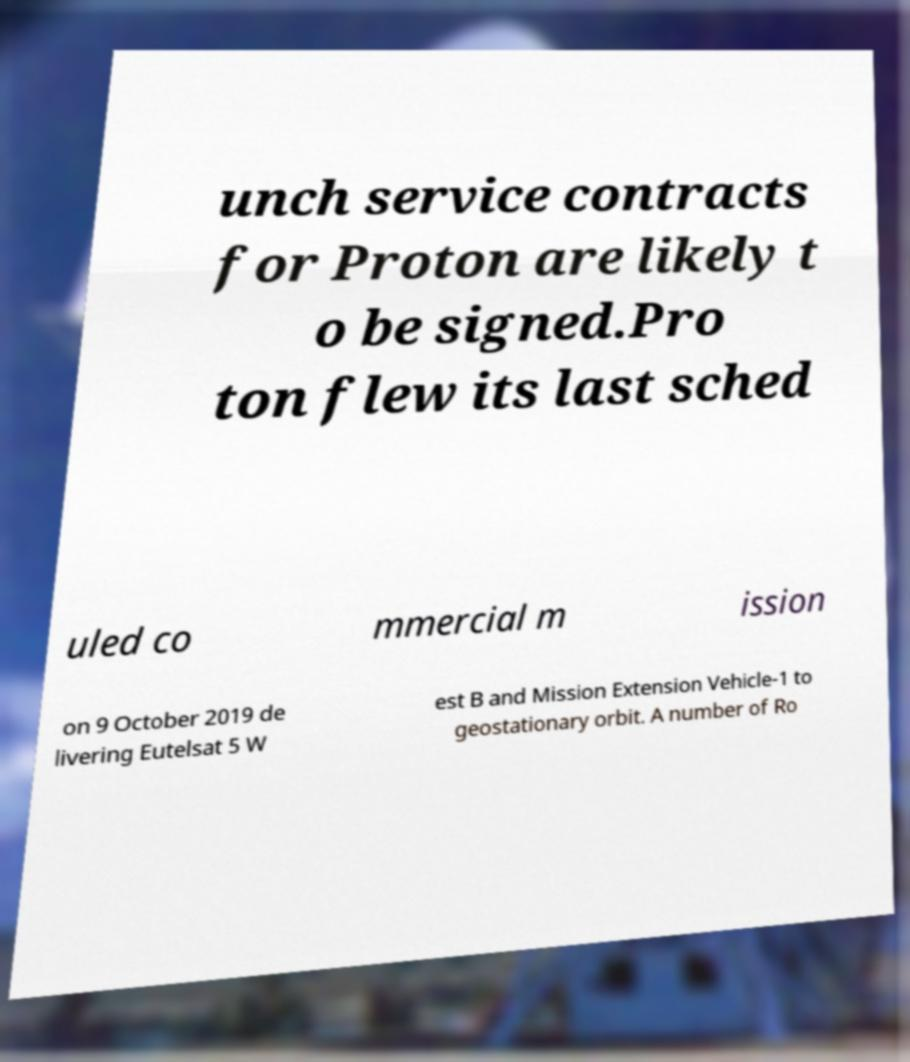Can you read and provide the text displayed in the image?This photo seems to have some interesting text. Can you extract and type it out for me? unch service contracts for Proton are likely t o be signed.Pro ton flew its last sched uled co mmercial m ission on 9 October 2019 de livering Eutelsat 5 W est B and Mission Extension Vehicle-1 to geostationary orbit. A number of Ro 